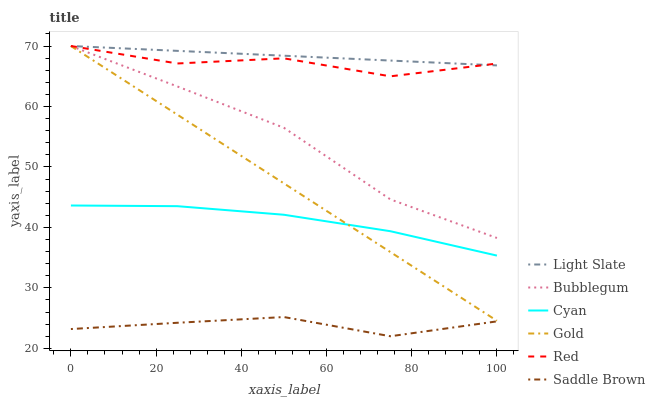Does Saddle Brown have the minimum area under the curve?
Answer yes or no. Yes. Does Light Slate have the maximum area under the curve?
Answer yes or no. Yes. Does Bubblegum have the minimum area under the curve?
Answer yes or no. No. Does Bubblegum have the maximum area under the curve?
Answer yes or no. No. Is Light Slate the smoothest?
Answer yes or no. Yes. Is Red the roughest?
Answer yes or no. Yes. Is Bubblegum the smoothest?
Answer yes or no. No. Is Bubblegum the roughest?
Answer yes or no. No. Does Saddle Brown have the lowest value?
Answer yes or no. Yes. Does Bubblegum have the lowest value?
Answer yes or no. No. Does Red have the highest value?
Answer yes or no. Yes. Does Cyan have the highest value?
Answer yes or no. No. Is Saddle Brown less than Red?
Answer yes or no. Yes. Is Bubblegum greater than Saddle Brown?
Answer yes or no. Yes. Does Red intersect Gold?
Answer yes or no. Yes. Is Red less than Gold?
Answer yes or no. No. Is Red greater than Gold?
Answer yes or no. No. Does Saddle Brown intersect Red?
Answer yes or no. No. 